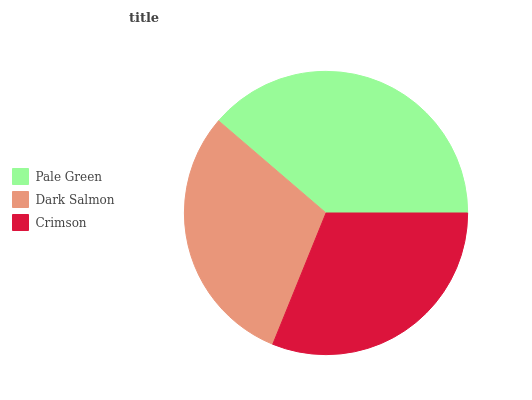Is Dark Salmon the minimum?
Answer yes or no. Yes. Is Pale Green the maximum?
Answer yes or no. Yes. Is Crimson the minimum?
Answer yes or no. No. Is Crimson the maximum?
Answer yes or no. No. Is Crimson greater than Dark Salmon?
Answer yes or no. Yes. Is Dark Salmon less than Crimson?
Answer yes or no. Yes. Is Dark Salmon greater than Crimson?
Answer yes or no. No. Is Crimson less than Dark Salmon?
Answer yes or no. No. Is Crimson the high median?
Answer yes or no. Yes. Is Crimson the low median?
Answer yes or no. Yes. Is Dark Salmon the high median?
Answer yes or no. No. Is Dark Salmon the low median?
Answer yes or no. No. 